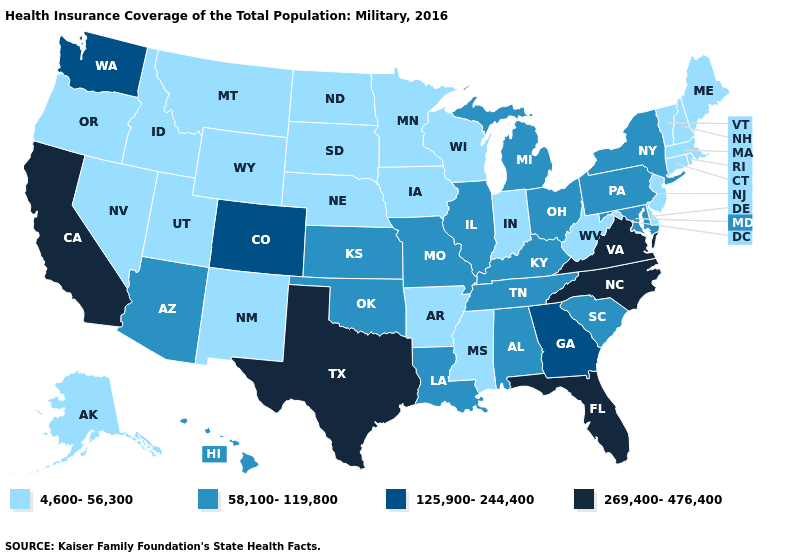Is the legend a continuous bar?
Keep it brief. No. Name the states that have a value in the range 125,900-244,400?
Answer briefly. Colorado, Georgia, Washington. Does Virginia have the highest value in the USA?
Give a very brief answer. Yes. Does the first symbol in the legend represent the smallest category?
Keep it brief. Yes. Name the states that have a value in the range 4,600-56,300?
Give a very brief answer. Alaska, Arkansas, Connecticut, Delaware, Idaho, Indiana, Iowa, Maine, Massachusetts, Minnesota, Mississippi, Montana, Nebraska, Nevada, New Hampshire, New Jersey, New Mexico, North Dakota, Oregon, Rhode Island, South Dakota, Utah, Vermont, West Virginia, Wisconsin, Wyoming. Among the states that border North Carolina , does Georgia have the lowest value?
Quick response, please. No. Does Wyoming have the same value as North Dakota?
Answer briefly. Yes. Name the states that have a value in the range 58,100-119,800?
Quick response, please. Alabama, Arizona, Hawaii, Illinois, Kansas, Kentucky, Louisiana, Maryland, Michigan, Missouri, New York, Ohio, Oklahoma, Pennsylvania, South Carolina, Tennessee. Does Missouri have the highest value in the MidWest?
Give a very brief answer. Yes. Does the first symbol in the legend represent the smallest category?
Give a very brief answer. Yes. What is the value of New Jersey?
Give a very brief answer. 4,600-56,300. What is the lowest value in the USA?
Give a very brief answer. 4,600-56,300. What is the highest value in the Northeast ?
Give a very brief answer. 58,100-119,800. Does Florida have the lowest value in the USA?
Short answer required. No. Among the states that border Alabama , does Florida have the highest value?
Write a very short answer. Yes. 